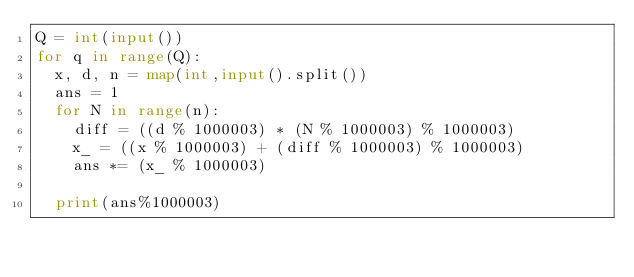Convert code to text. <code><loc_0><loc_0><loc_500><loc_500><_Python_>Q = int(input())
for q in range(Q):
  x, d, n = map(int,input().split())
  ans = 1
  for N in range(n):
    diff = ((d % 1000003) * (N % 1000003) % 1000003)
    x_ = ((x % 1000003) + (diff % 1000003) % 1000003)
    ans *= (x_ % 1000003)
    
  print(ans%1000003)</code> 